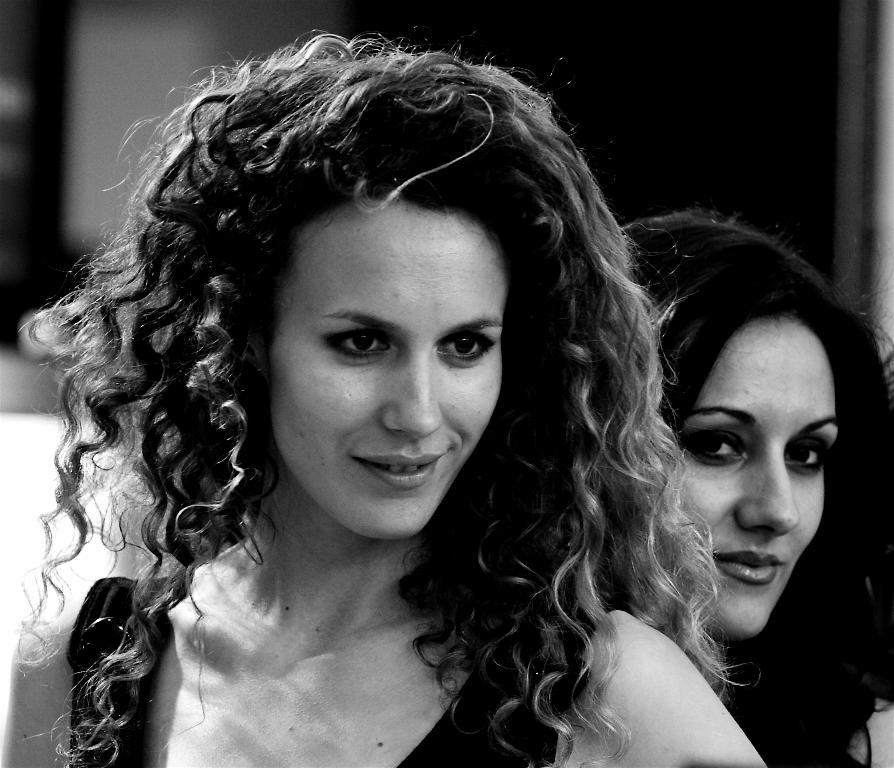What is the color scheme of the image? The image is black and white. How many people are in the image? There are two women in the image. What direction are the women looking? The women are looking to the right. What expression do the women have? The women are smiling. Can you describe the background of the image? The background of the image is blurred. What type of tooth is visible in the image? There is no tooth present in the image. What kind of crack is visible in the background of the image? There is no crack visible in the background of the image. 